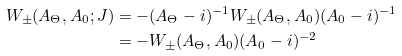<formula> <loc_0><loc_0><loc_500><loc_500>W _ { \pm } ( A _ { \Theta } , A _ { 0 } ; J ) & = - ( A _ { \Theta } - i ) ^ { - 1 } W _ { \pm } ( A _ { \Theta } , A _ { 0 } ) ( A _ { 0 } - i ) ^ { - 1 } \\ & = - W _ { \pm } ( A _ { \Theta } , A _ { 0 } ) ( A _ { 0 } - i ) ^ { - 2 }</formula> 